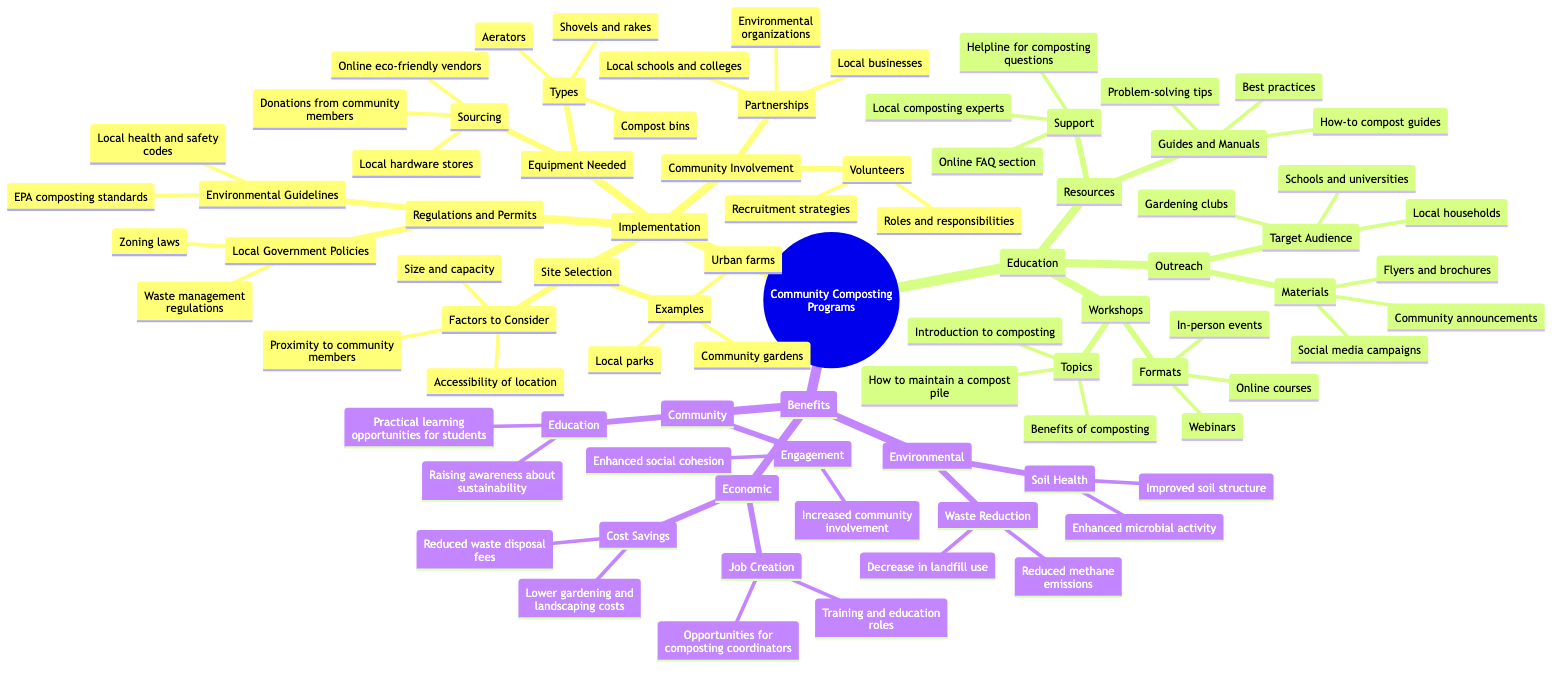What are the factors to consider in site selection? The diagram shows that under the "Site Selection" section, there are three specific factors outlined: proximity to community members, accessibility of location, and size and capacity.
Answer: Proximity to community members, Accessibility of location, Size and capacity How many types of equipment are listed under Equipment Needed? In the "Equipment Needed" section, there are three types of equipment mentioned: compost bins, aerators, and shovels and rakes.
Answer: 3 What are some examples of locations for community composting? The diagram lists three examples under "Site Selection": local parks, community gardens, and urban farms.
Answer: Local parks, Community gardens, Urban farms What is the target audience for outreach efforts? The "Outreach" segment of the diagram identifies three target audiences: schools and universities, local households, and gardening clubs.
Answer: Schools and universities, Local households, Gardening clubs What two local government policies must be considered for regulations and permits? Under the "Regulations and Permits" section, the diagram specifies two local government policies: waste management regulations and zoning laws.
Answer: Waste management regulations, Zoning laws What type of support is available for composting questions? The "Support" section under "Resources" indicates that there is a helpline for composting questions, among other resources.
Answer: Helpline for composting questions What are the two environmental benefits of community composting? The "Benefits" section lists two specific environmental benefits: waste reduction and soil health.
Answer: Waste Reduction, Soil Health How many topics are covered in the workshops? The diagram indicates three topics that are covered in the workshops: introduction to composting, benefits of composting, and how to maintain a compost pile, so the count is three.
Answer: 3 What type of partnerships are recommended for community involvement? The "Partnerships" subsection under "Community Involvement" suggests partnerships with local schools and colleges, environmental organizations, and local businesses.
Answer: Local schools and colleges, Environmental organizations, Local businesses 